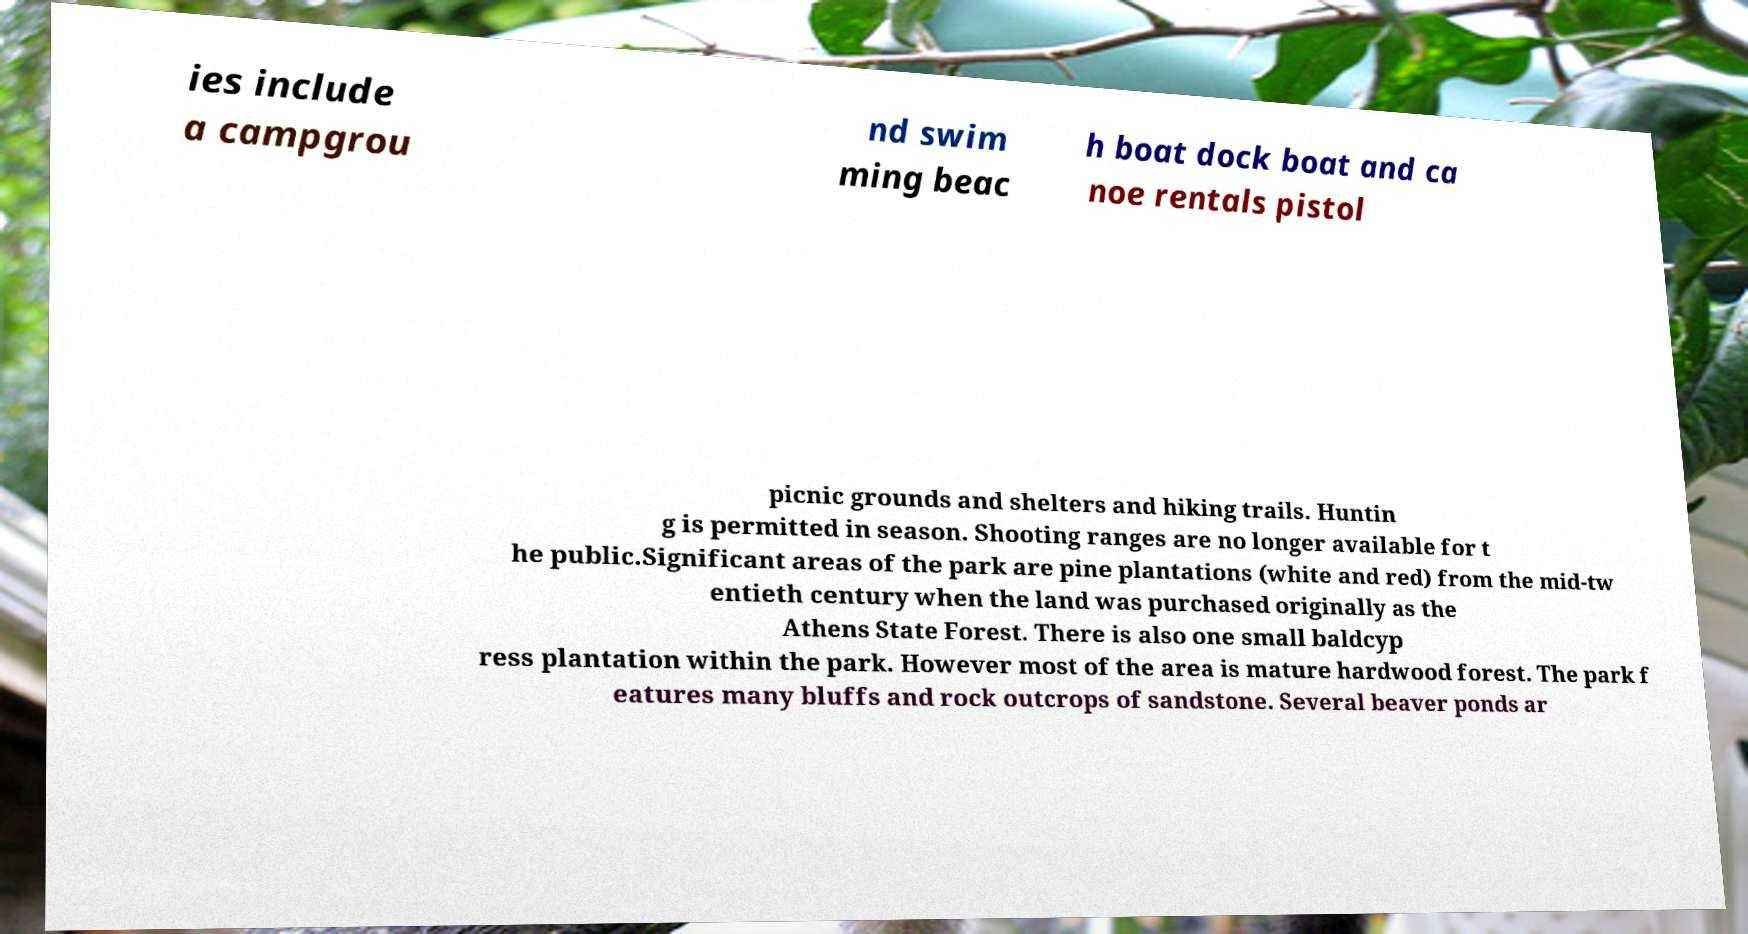There's text embedded in this image that I need extracted. Can you transcribe it verbatim? ies include a campgrou nd swim ming beac h boat dock boat and ca noe rentals pistol picnic grounds and shelters and hiking trails. Huntin g is permitted in season. Shooting ranges are no longer available for t he public.Significant areas of the park are pine plantations (white and red) from the mid-tw entieth century when the land was purchased originally as the Athens State Forest. There is also one small baldcyp ress plantation within the park. However most of the area is mature hardwood forest. The park f eatures many bluffs and rock outcrops of sandstone. Several beaver ponds ar 